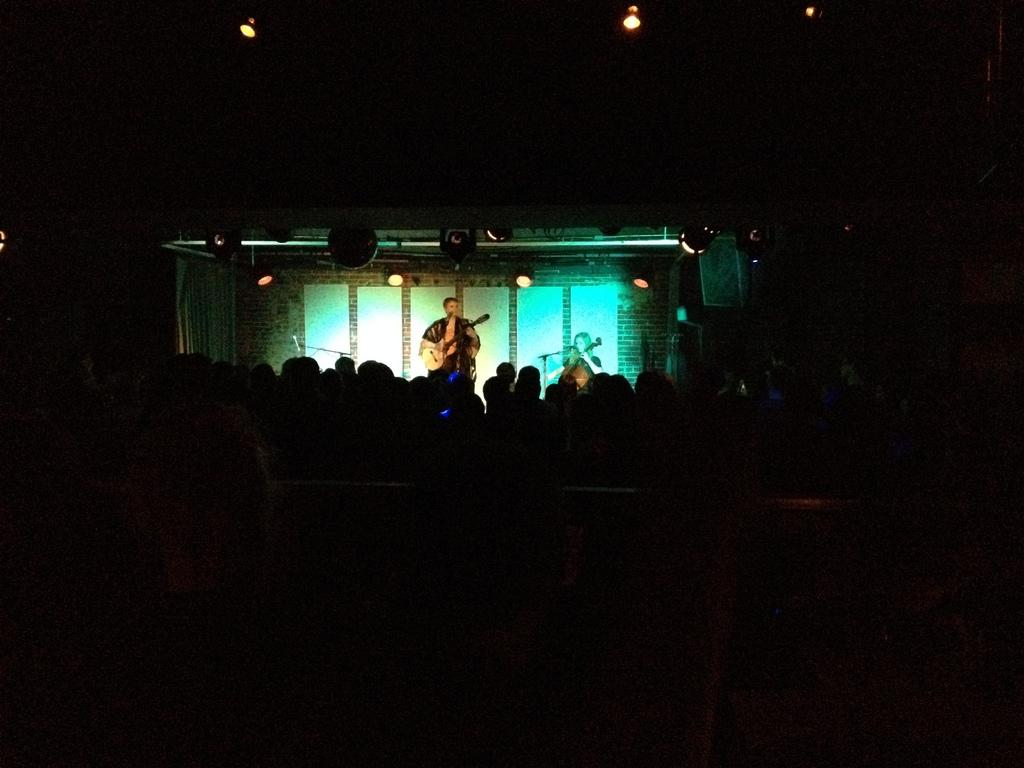How many people are in the image? There are persons in the image, but the exact number is not specified. What is the overall appearance of the image? The image has a dark appearance. What is the person holding in the image? There is a person standing and holding a guitar in the image. What can be seen in the background of the image? There are lights visible in the background, and there are boards attached to the wall. What type of science experiment is being conducted in the image? There is no indication of a science experiment in the image; it features a person holding a guitar and other background elements. Is there any evidence of an earthquake in the image? There is no mention or indication of an earthquake in the image. 